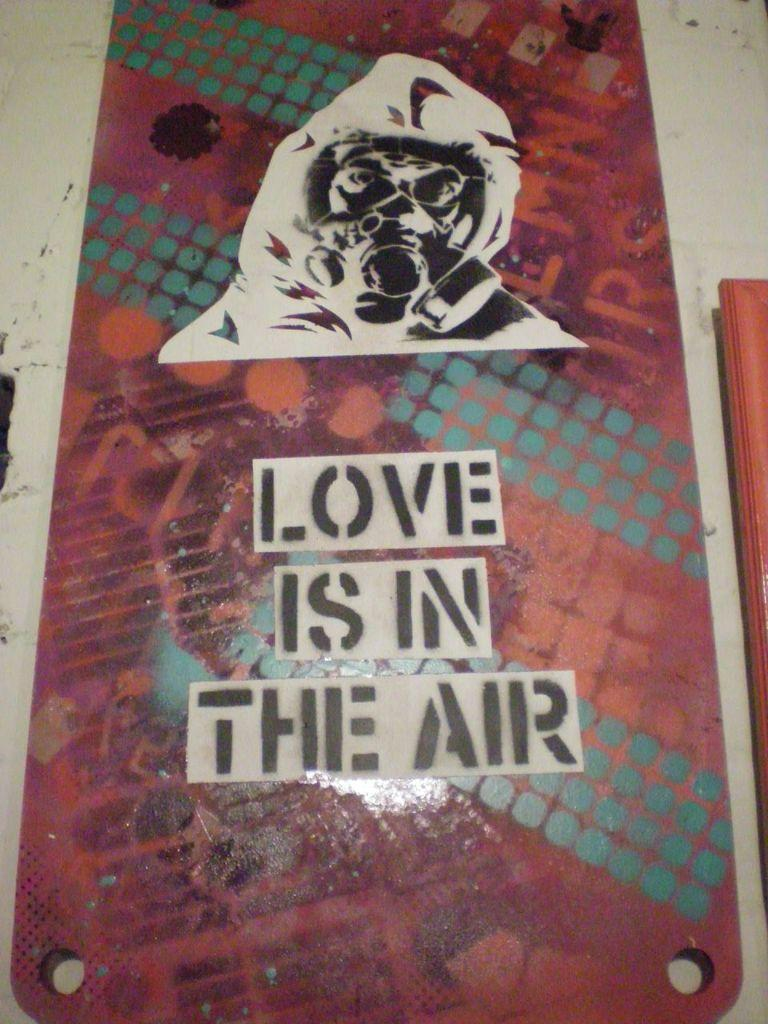What is the main object in the image that has an image and text? There is an object with an image and text in the image. What is the background or surface on which the object with an image and text is placed? The object with an image and text is placed on a white surface. Are there any other objects visible in the image? Yes, there is another object on the right side of the image. What type of powder can be seen falling from the object with an image and text in the image? There is no powder visible in the image; the object with an image and text is placed on a white surface, and there is another object on the right side of the image. 